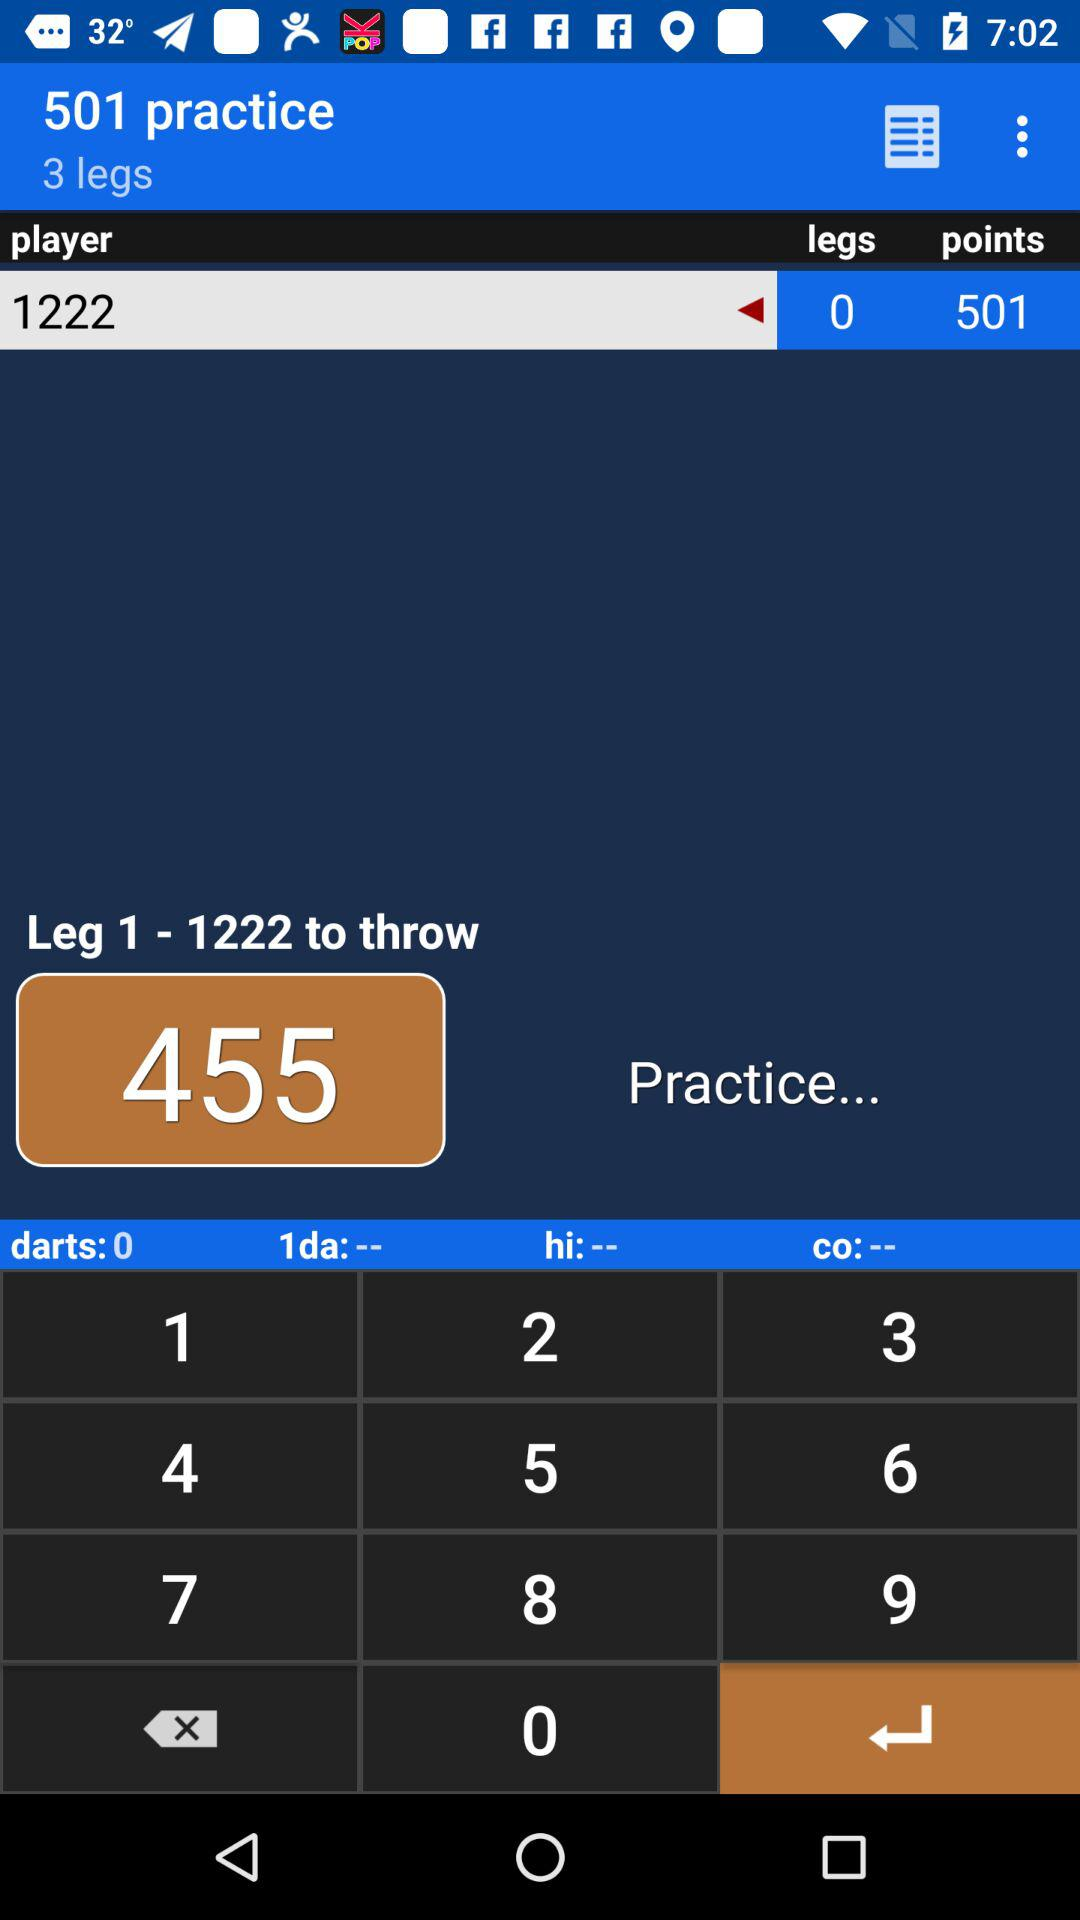How many points are there? There are 501 points. 